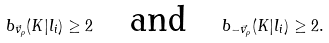<formula> <loc_0><loc_0><loc_500><loc_500>b _ { \vec { v } _ { \rho } } ( K | l _ { i } ) \geq 2 \quad \text {and} \quad b _ { - \vec { v } _ { \rho } } ( K | l _ { i } ) \geq 2 .</formula> 